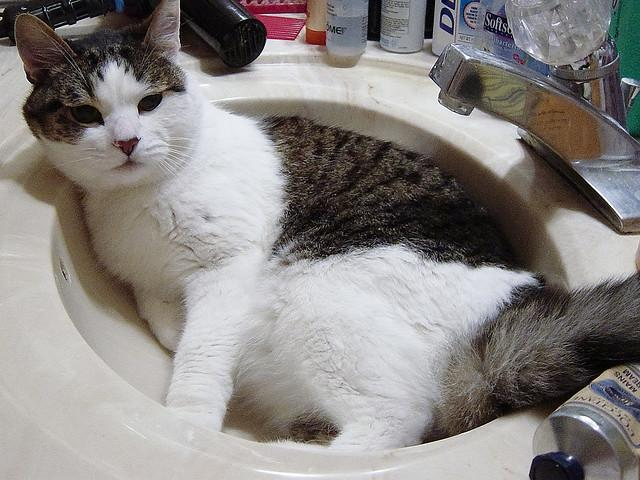Why is the cat in the sink?

Choices:
A) to sleep
B) to eat
C) to bathe
D) to comb to sleep 